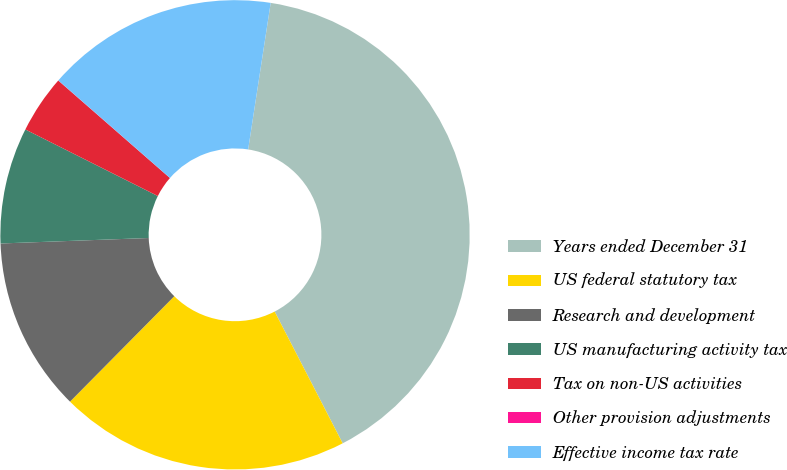<chart> <loc_0><loc_0><loc_500><loc_500><pie_chart><fcel>Years ended December 31<fcel>US federal statutory tax<fcel>Research and development<fcel>US manufacturing activity tax<fcel>Tax on non-US activities<fcel>Other provision adjustments<fcel>Effective income tax rate<nl><fcel>39.99%<fcel>20.0%<fcel>12.0%<fcel>8.0%<fcel>4.01%<fcel>0.01%<fcel>16.0%<nl></chart> 